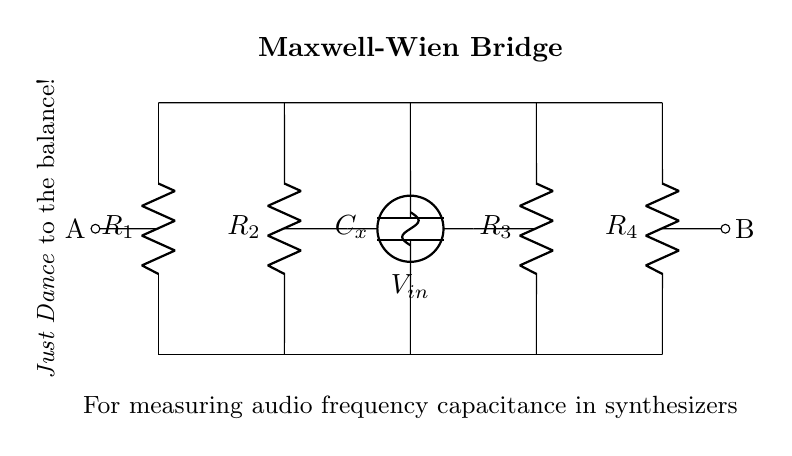What type of bridge is shown in the circuit? The circuit is labeled as a Maxwell-Wien Bridge, which is specifically designed for measuring capacitance.
Answer: Maxwell-Wien Bridge What does the component labeled C_x represent? The component C_x is a capacitor, signifying the unknown capacitance that needs to be measured in the circuit.
Answer: Capacitor How many resistors are present in this circuit? The circuit diagram shows four resistors labeled as R_1, R_2, R_3, and R_4.
Answer: Four What is the purpose of the voltage source in the circuit? The voltage source provides a sinusoidal input voltage that is necessary for the operation of the Maxwell-Wien Bridge, allowing for the measurement of capacitance.
Answer: Sinusoidal input What does the path from A to B represent? The path from A to B indicates the points where the output voltage is measured, typically to ascertain the balance condition of the bridge.
Answer: Output measurement Why is balancing the bridge important? Balancing the bridge is essential because it allows for accurate readings of the unknown capacitance by ensuring that the voltage across the bridge is zero, indicating that the impedances are equal.
Answer: Accurate capacitance measurement What musical reference is included in the diagram? The text "Just Dance to the balance!" suggests a reference to Lady Gaga's song "Just Dance," linking the bridge's balancing act with the theme of music and dance.
Answer: Just Dance 